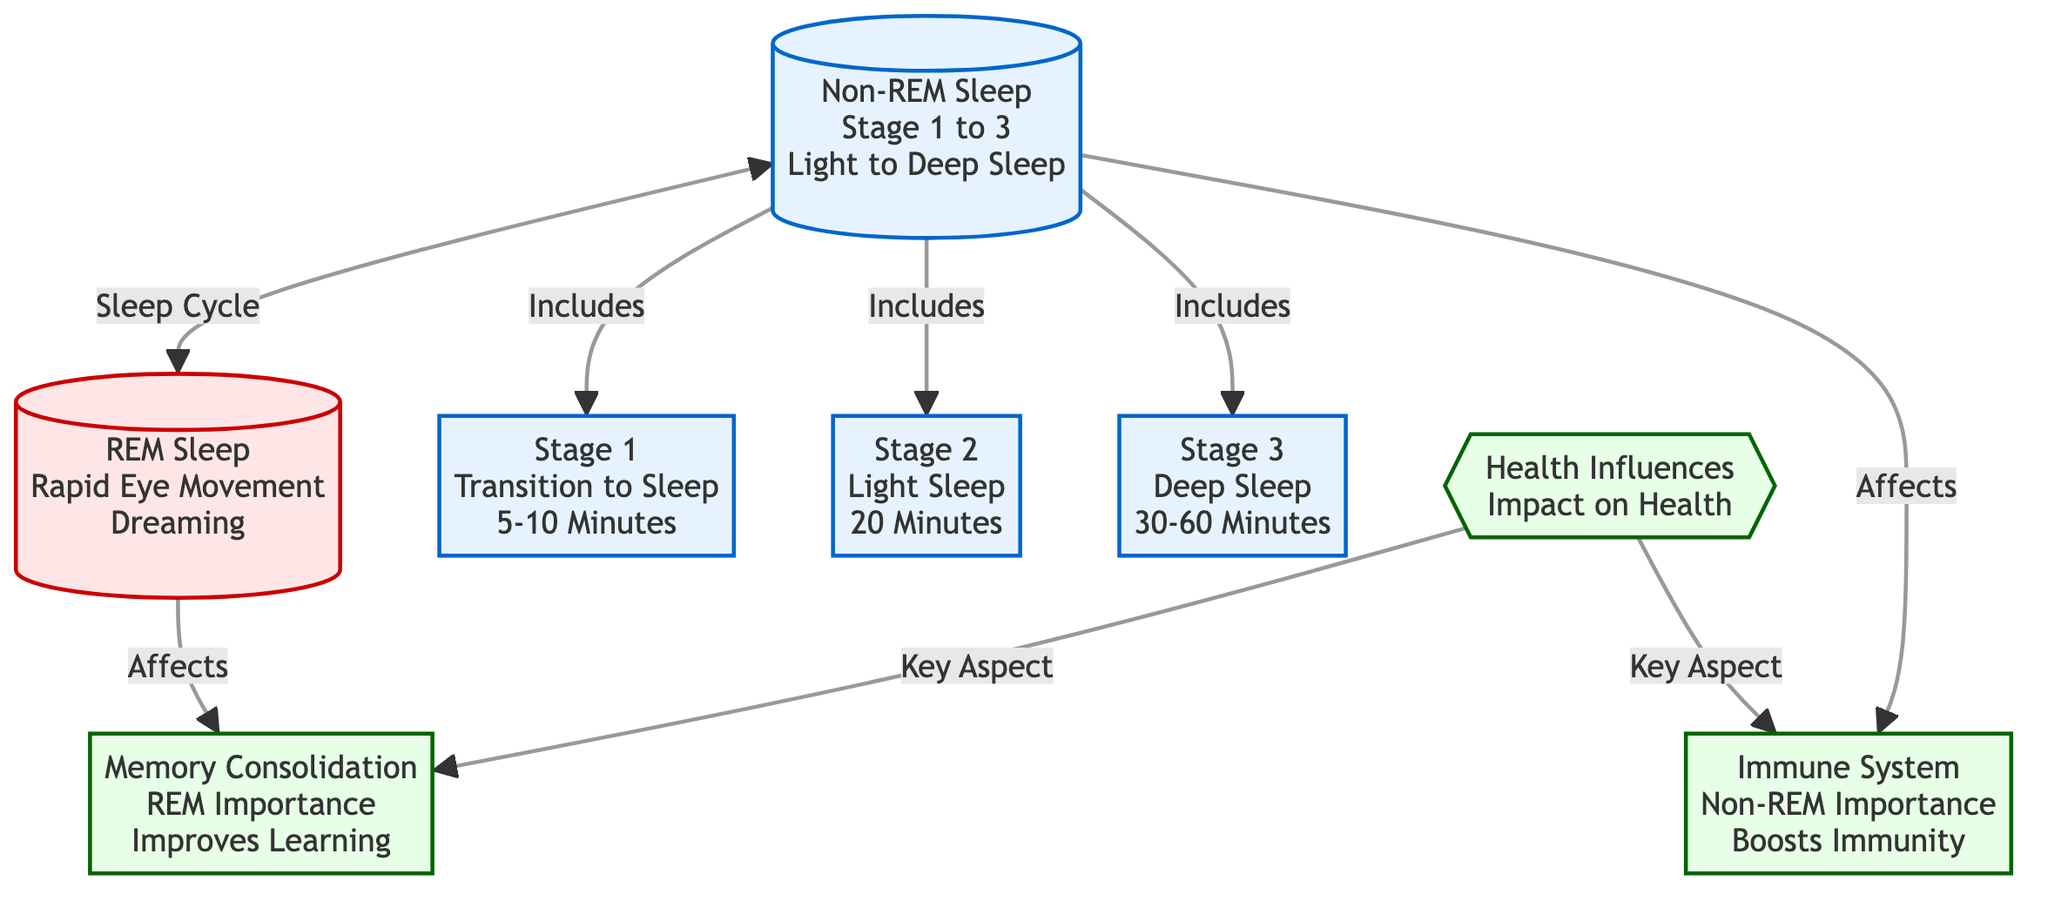What is the duration of Stage 1 in the sleep cycle? According to the diagram, Stage 1 (Transition to Sleep) lasts 5-10 Minutes. The information is directly listed under the corresponding node for Stage 1.
Answer: 5-10 Minutes How many total stages are in Non-REM sleep? The diagram lists three distinct stages under Non-REM: Stage 1, Stage 2, and Stage 3. By counting these three nodes, we confirm the total.
Answer: 3 What stage of sleep is associated with dreaming? The diagram clearly identifies REM Sleep as the stage associated with dreaming, indicated as Rapid Eye Movement in the node label.
Answer: REM Sleep Which stage of Non-REM sleep lasts the longest? The longest duration stage among Non-REM is Stage 3, which lasts 30-60 Minutes. This information is presented directly next to the node for Stage 3.
Answer: 30-60 Minutes What health influence is linked to REM sleep according to the diagram? The diagram establishes a relationship between REM sleep and Memory Consolidation, indicating its importance for improving learning as per the connected node.
Answer: Memory Consolidation How does Non-REM sleep affect health? The diagram specifies Non-REM sleep's health influence is related to boosting the immune system. This connection is evident in the arrow linking Non-REM sleep to the health-related node.
Answer: Boosts Immunity What are the two key aspects of health influences shown in the diagram? The two key aspects regarding health influences are Memory Consolidation and Boosts Immunity. Both are listed independently within health-related nodes that branch from the central health influences node.
Answer: Memory Consolidation, Boosts Immunity Which node represents Light Sleep? Light Sleep is represented as Stage 2 in the diagram, with the duration specified as 20 Minutes next to the node label. This direct correspondence clearly identifies Stage 2 as Light Sleep.
Answer: Stage 2 How does Non-REM sleep correlate with the immune system? Non-REM sleep is directly linked to the health influence of boosting immunity, as shown in the diagram. This connection is evident where the Non-REM node points to the corresponding health aspect.
Answer: Boosts Immunity 